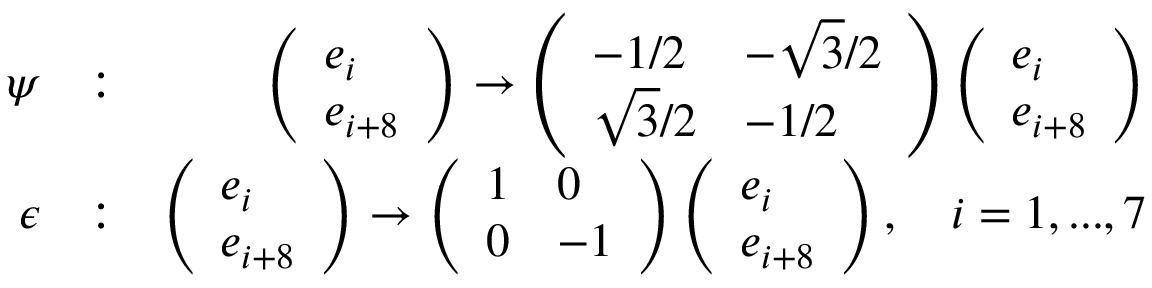<formula> <loc_0><loc_0><loc_500><loc_500>\begin{array} { r l r } { \psi } & { \colon } & { \left ( \begin{array} { l } { e _ { i } } \\ { e _ { i + 8 } } \end{array} \right ) \rightarrow \left ( \begin{array} { l l } { - 1 / 2 } & { - \sqrt { 3 } / 2 } \\ { \sqrt { 3 } / 2 } & { - 1 / 2 } \end{array} \right ) \left ( \begin{array} { l } { e _ { i } } \\ { e _ { i + 8 } } \end{array} \right ) } \\ { \epsilon } & { \colon } & { \left ( \begin{array} { l } { e _ { i } } \\ { e _ { i + 8 } } \end{array} \right ) \rightarrow \left ( \begin{array} { l l } { 1 } & { 0 } \\ { 0 } & { - 1 } \end{array} \right ) \left ( \begin{array} { l } { e _ { i } } \\ { e _ { i + 8 } } \end{array} \right ) , \quad i = 1 , \dots , 7 } \end{array}</formula> 